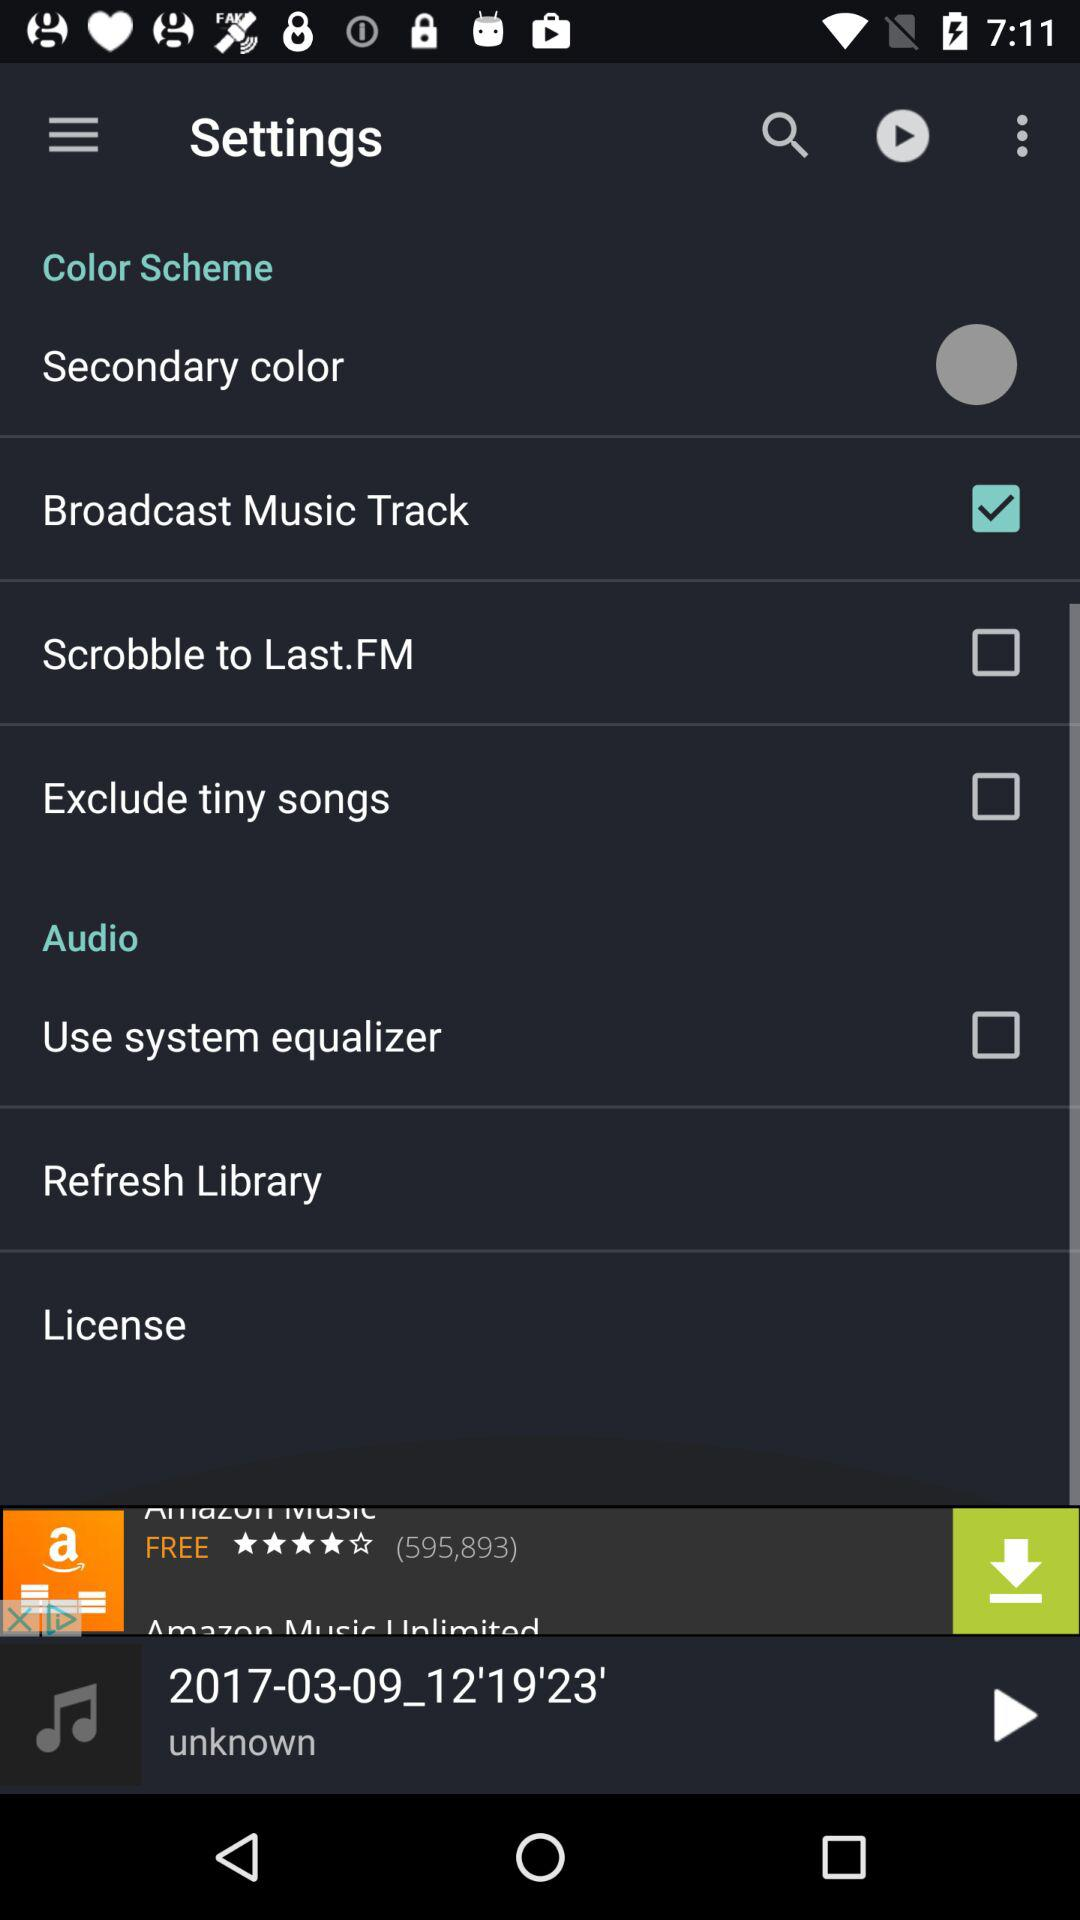Which colour scheme was selected?
When the provided information is insufficient, respond with <no answer>. <no answer> 